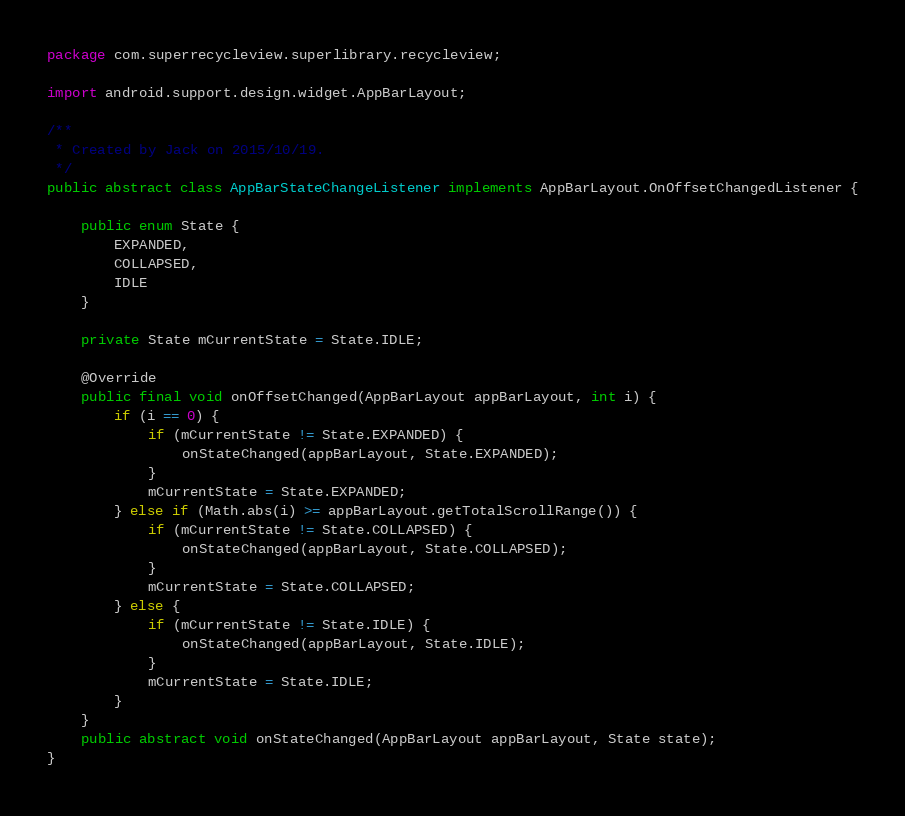Convert code to text. <code><loc_0><loc_0><loc_500><loc_500><_Java_>package com.superrecycleview.superlibrary.recycleview;

import android.support.design.widget.AppBarLayout;

/**
 * Created by Jack on 2015/10/19.
 */
public abstract class AppBarStateChangeListener implements AppBarLayout.OnOffsetChangedListener {

    public enum State {
        EXPANDED,
        COLLAPSED,
        IDLE
    }

    private State mCurrentState = State.IDLE;

    @Override
    public final void onOffsetChanged(AppBarLayout appBarLayout, int i) {
        if (i == 0) {
            if (mCurrentState != State.EXPANDED) {
                onStateChanged(appBarLayout, State.EXPANDED);
            }
            mCurrentState = State.EXPANDED;
        } else if (Math.abs(i) >= appBarLayout.getTotalScrollRange()) {
            if (mCurrentState != State.COLLAPSED) {
                onStateChanged(appBarLayout, State.COLLAPSED);
            }
            mCurrentState = State.COLLAPSED;
        } else {
            if (mCurrentState != State.IDLE) {
                onStateChanged(appBarLayout, State.IDLE);
            }
            mCurrentState = State.IDLE;
        }
    }
    public abstract void onStateChanged(AppBarLayout appBarLayout, State state);
}

</code> 